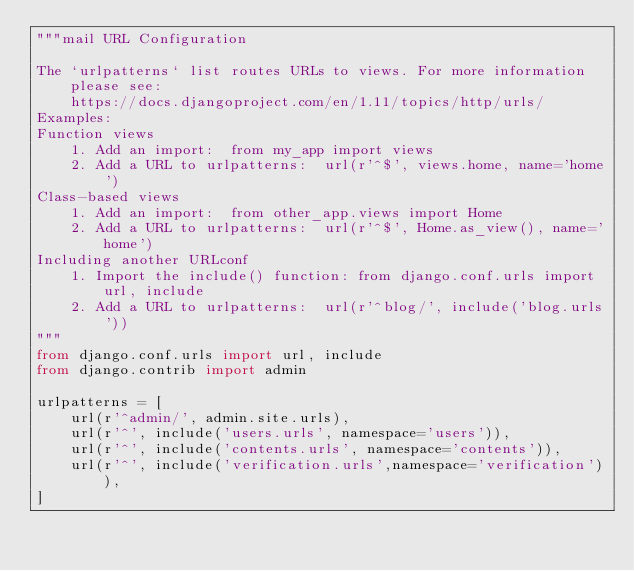Convert code to text. <code><loc_0><loc_0><loc_500><loc_500><_Python_>"""mail URL Configuration

The `urlpatterns` list routes URLs to views. For more information please see:
    https://docs.djangoproject.com/en/1.11/topics/http/urls/
Examples:
Function views
    1. Add an import:  from my_app import views
    2. Add a URL to urlpatterns:  url(r'^$', views.home, name='home')
Class-based views
    1. Add an import:  from other_app.views import Home
    2. Add a URL to urlpatterns:  url(r'^$', Home.as_view(), name='home')
Including another URLconf
    1. Import the include() function: from django.conf.urls import url, include
    2. Add a URL to urlpatterns:  url(r'^blog/', include('blog.urls'))
"""
from django.conf.urls import url, include
from django.contrib import admin

urlpatterns = [
    url(r'^admin/', admin.site.urls),
    url(r'^', include('users.urls', namespace='users')),
    url(r'^', include('contents.urls', namespace='contents')),
    url(r'^', include('verification.urls',namespace='verification')),
]
</code> 